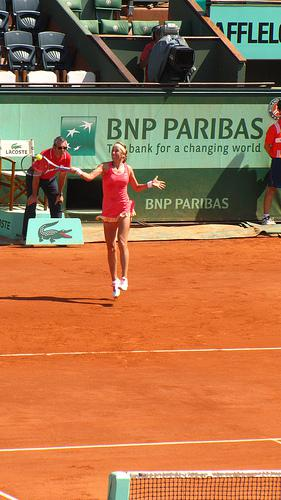Question: who is hitting the ball?
Choices:
A. Baseball player.
B. Field hockey player.
C. Softball player.
D. Tennis player.
Answer with the letter. Answer: D Question: how many people can at least be partially seen?
Choices:
A. Five.
B. Two.
C. Four.
D. Six.
Answer with the letter. Answer: C Question: what sport is being played?
Choices:
A. Baseball.
B. Basketball.
C. Tennis.
D. Soccer.
Answer with the letter. Answer: C 